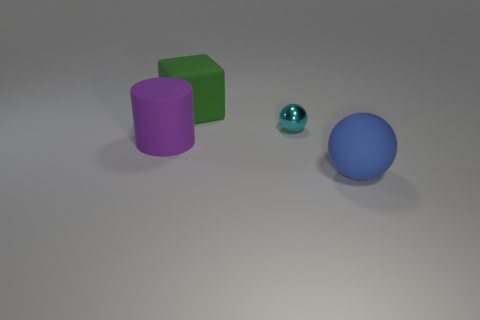What can you infer about the texture of the objects? The objects appear to have a matte finish, with the exception of the small teal sphere which has a reflective surface, as you can see highlights suggesting a slightly glossy texture. Is there anything in the image that might suggest its scale or the actual size of these objects? Without a familiar object or a known reference for size comparison, the actual scale is ambiguous. However, the way the objects are rendered tends to give them an appearance of being small, like models or toys, rather than life-sized objects. 